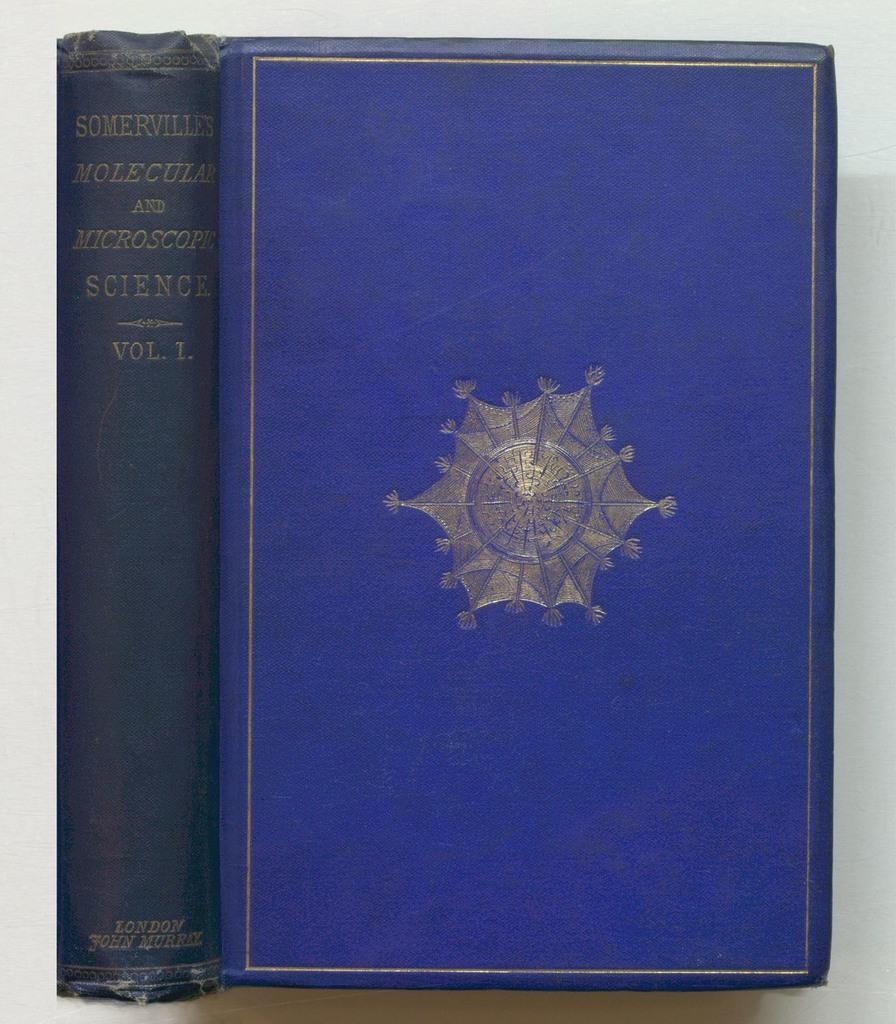<image>
Relay a brief, clear account of the picture shown. a copy of somerville's Molecular and microscopic science volume one. 